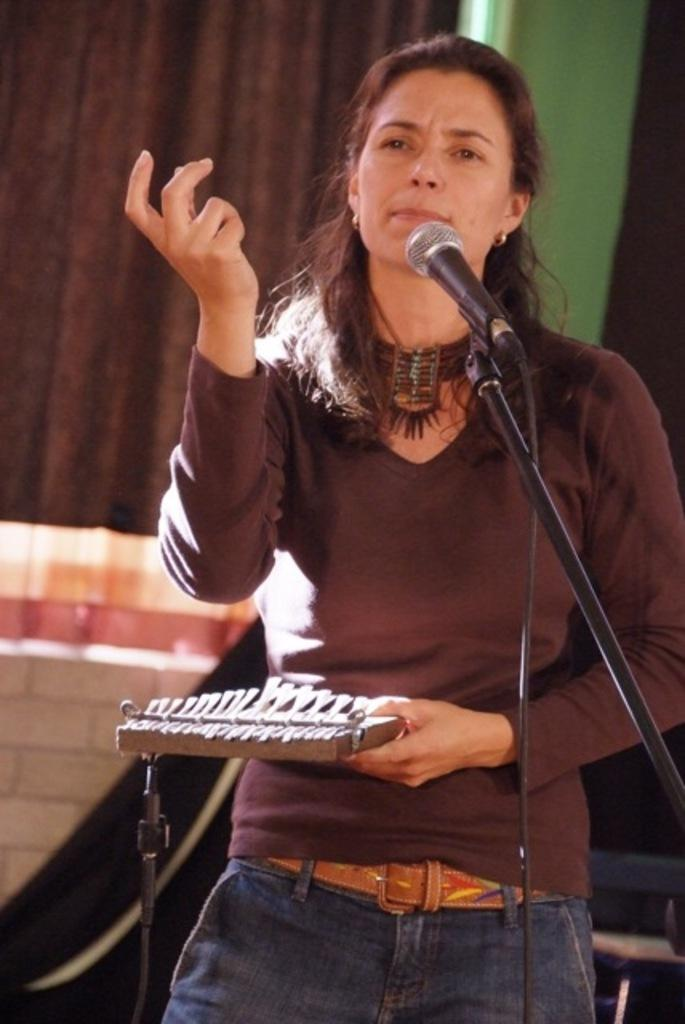Who is the main subject in the image? There is a woman in the image. What is the woman doing in the image? The woman is standing in front of a mic and a stand. What is the woman wearing in the image? The woman is wearing a brown color T-shirt. What can be seen in the background of the image? There is a brown color curtain and a wall visible in the background of the image. How many rings does the donkey have on its legs in the image? There is no donkey present in the image, so it is not possible to determine how many rings it might have on its legs. 